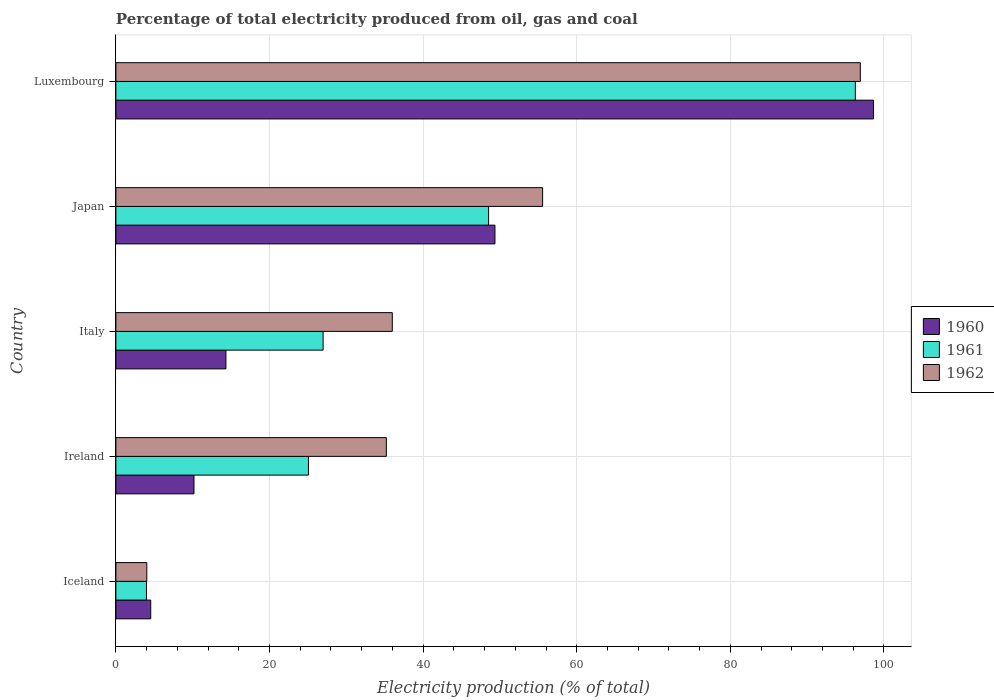How many different coloured bars are there?
Make the answer very short. 3. How many groups of bars are there?
Make the answer very short. 5. Are the number of bars on each tick of the Y-axis equal?
Give a very brief answer. Yes. How many bars are there on the 5th tick from the top?
Your response must be concise. 3. How many bars are there on the 4th tick from the bottom?
Your answer should be very brief. 3. In how many cases, is the number of bars for a given country not equal to the number of legend labels?
Provide a succinct answer. 0. What is the electricity production in in 1962 in Italy?
Your answer should be compact. 35.99. Across all countries, what is the maximum electricity production in in 1962?
Your answer should be very brief. 96.92. Across all countries, what is the minimum electricity production in in 1960?
Your answer should be compact. 4.54. In which country was the electricity production in in 1961 maximum?
Your answer should be compact. Luxembourg. What is the total electricity production in in 1962 in the graph?
Offer a terse response. 227.7. What is the difference between the electricity production in in 1961 in Iceland and that in Luxembourg?
Make the answer very short. -92.29. What is the difference between the electricity production in in 1960 in Japan and the electricity production in in 1961 in Luxembourg?
Your answer should be compact. -46.92. What is the average electricity production in in 1961 per country?
Offer a terse response. 40.16. What is the difference between the electricity production in in 1960 and electricity production in in 1961 in Japan?
Provide a short and direct response. 0.83. What is the ratio of the electricity production in in 1962 in Ireland to that in Luxembourg?
Offer a terse response. 0.36. Is the difference between the electricity production in in 1960 in Ireland and Japan greater than the difference between the electricity production in in 1961 in Ireland and Japan?
Your response must be concise. No. What is the difference between the highest and the second highest electricity production in in 1962?
Keep it short and to the point. 41.36. What is the difference between the highest and the lowest electricity production in in 1962?
Ensure brevity in your answer.  92.89. In how many countries, is the electricity production in in 1962 greater than the average electricity production in in 1962 taken over all countries?
Your response must be concise. 2. Is it the case that in every country, the sum of the electricity production in in 1960 and electricity production in in 1962 is greater than the electricity production in in 1961?
Ensure brevity in your answer.  Yes. How many bars are there?
Provide a short and direct response. 15. Are all the bars in the graph horizontal?
Provide a succinct answer. Yes. How many countries are there in the graph?
Offer a very short reply. 5. Are the values on the major ticks of X-axis written in scientific E-notation?
Your answer should be compact. No. Does the graph contain any zero values?
Ensure brevity in your answer.  No. Does the graph contain grids?
Provide a short and direct response. Yes. Where does the legend appear in the graph?
Give a very brief answer. Center right. How are the legend labels stacked?
Your response must be concise. Vertical. What is the title of the graph?
Ensure brevity in your answer.  Percentage of total electricity produced from oil, gas and coal. Does "1963" appear as one of the legend labels in the graph?
Your answer should be compact. No. What is the label or title of the X-axis?
Make the answer very short. Electricity production (% of total). What is the label or title of the Y-axis?
Your answer should be very brief. Country. What is the Electricity production (% of total) of 1960 in Iceland?
Your answer should be very brief. 4.54. What is the Electricity production (% of total) of 1961 in Iceland?
Ensure brevity in your answer.  3.98. What is the Electricity production (% of total) of 1962 in Iceland?
Your answer should be very brief. 4.03. What is the Electricity production (% of total) in 1960 in Ireland?
Keep it short and to the point. 10.17. What is the Electricity production (% of total) of 1961 in Ireland?
Provide a succinct answer. 25.07. What is the Electricity production (% of total) of 1962 in Ireland?
Provide a short and direct response. 35.21. What is the Electricity production (% of total) in 1960 in Italy?
Offer a very short reply. 14.33. What is the Electricity production (% of total) in 1961 in Italy?
Your answer should be compact. 26.98. What is the Electricity production (% of total) in 1962 in Italy?
Your answer should be very brief. 35.99. What is the Electricity production (% of total) in 1960 in Japan?
Keep it short and to the point. 49.35. What is the Electricity production (% of total) in 1961 in Japan?
Keep it short and to the point. 48.52. What is the Electricity production (% of total) in 1962 in Japan?
Your response must be concise. 55.56. What is the Electricity production (% of total) of 1960 in Luxembourg?
Keep it short and to the point. 98.63. What is the Electricity production (% of total) in 1961 in Luxembourg?
Make the answer very short. 96.27. What is the Electricity production (% of total) of 1962 in Luxembourg?
Provide a succinct answer. 96.92. Across all countries, what is the maximum Electricity production (% of total) of 1960?
Offer a terse response. 98.63. Across all countries, what is the maximum Electricity production (% of total) in 1961?
Ensure brevity in your answer.  96.27. Across all countries, what is the maximum Electricity production (% of total) of 1962?
Offer a very short reply. 96.92. Across all countries, what is the minimum Electricity production (% of total) of 1960?
Your answer should be very brief. 4.54. Across all countries, what is the minimum Electricity production (% of total) of 1961?
Keep it short and to the point. 3.98. Across all countries, what is the minimum Electricity production (% of total) in 1962?
Ensure brevity in your answer.  4.03. What is the total Electricity production (% of total) of 1960 in the graph?
Provide a succinct answer. 177.02. What is the total Electricity production (% of total) of 1961 in the graph?
Your response must be concise. 200.82. What is the total Electricity production (% of total) of 1962 in the graph?
Provide a succinct answer. 227.7. What is the difference between the Electricity production (% of total) of 1960 in Iceland and that in Ireland?
Provide a succinct answer. -5.63. What is the difference between the Electricity production (% of total) in 1961 in Iceland and that in Ireland?
Provide a short and direct response. -21.09. What is the difference between the Electricity production (% of total) of 1962 in Iceland and that in Ireland?
Give a very brief answer. -31.19. What is the difference between the Electricity production (% of total) in 1960 in Iceland and that in Italy?
Offer a terse response. -9.79. What is the difference between the Electricity production (% of total) in 1961 in Iceland and that in Italy?
Keep it short and to the point. -23. What is the difference between the Electricity production (% of total) of 1962 in Iceland and that in Italy?
Ensure brevity in your answer.  -31.96. What is the difference between the Electricity production (% of total) of 1960 in Iceland and that in Japan?
Offer a terse response. -44.81. What is the difference between the Electricity production (% of total) in 1961 in Iceland and that in Japan?
Make the answer very short. -44.54. What is the difference between the Electricity production (% of total) of 1962 in Iceland and that in Japan?
Provide a short and direct response. -51.53. What is the difference between the Electricity production (% of total) of 1960 in Iceland and that in Luxembourg?
Offer a very short reply. -94.1. What is the difference between the Electricity production (% of total) of 1961 in Iceland and that in Luxembourg?
Keep it short and to the point. -92.29. What is the difference between the Electricity production (% of total) in 1962 in Iceland and that in Luxembourg?
Ensure brevity in your answer.  -92.89. What is the difference between the Electricity production (% of total) of 1960 in Ireland and that in Italy?
Your answer should be compact. -4.16. What is the difference between the Electricity production (% of total) of 1961 in Ireland and that in Italy?
Provide a short and direct response. -1.91. What is the difference between the Electricity production (% of total) of 1962 in Ireland and that in Italy?
Ensure brevity in your answer.  -0.78. What is the difference between the Electricity production (% of total) of 1960 in Ireland and that in Japan?
Offer a terse response. -39.18. What is the difference between the Electricity production (% of total) of 1961 in Ireland and that in Japan?
Your answer should be compact. -23.45. What is the difference between the Electricity production (% of total) of 1962 in Ireland and that in Japan?
Your answer should be very brief. -20.34. What is the difference between the Electricity production (% of total) in 1960 in Ireland and that in Luxembourg?
Provide a succinct answer. -88.47. What is the difference between the Electricity production (% of total) of 1961 in Ireland and that in Luxembourg?
Give a very brief answer. -71.2. What is the difference between the Electricity production (% of total) in 1962 in Ireland and that in Luxembourg?
Offer a terse response. -61.71. What is the difference between the Electricity production (% of total) in 1960 in Italy and that in Japan?
Keep it short and to the point. -35.02. What is the difference between the Electricity production (% of total) of 1961 in Italy and that in Japan?
Your answer should be very brief. -21.55. What is the difference between the Electricity production (% of total) of 1962 in Italy and that in Japan?
Your response must be concise. -19.57. What is the difference between the Electricity production (% of total) in 1960 in Italy and that in Luxembourg?
Provide a succinct answer. -84.31. What is the difference between the Electricity production (% of total) in 1961 in Italy and that in Luxembourg?
Keep it short and to the point. -69.29. What is the difference between the Electricity production (% of total) in 1962 in Italy and that in Luxembourg?
Your answer should be very brief. -60.93. What is the difference between the Electricity production (% of total) of 1960 in Japan and that in Luxembourg?
Provide a succinct answer. -49.28. What is the difference between the Electricity production (% of total) in 1961 in Japan and that in Luxembourg?
Your response must be concise. -47.75. What is the difference between the Electricity production (% of total) of 1962 in Japan and that in Luxembourg?
Your answer should be compact. -41.36. What is the difference between the Electricity production (% of total) of 1960 in Iceland and the Electricity production (% of total) of 1961 in Ireland?
Your answer should be very brief. -20.53. What is the difference between the Electricity production (% of total) in 1960 in Iceland and the Electricity production (% of total) in 1962 in Ireland?
Give a very brief answer. -30.67. What is the difference between the Electricity production (% of total) in 1961 in Iceland and the Electricity production (% of total) in 1962 in Ireland?
Your response must be concise. -31.23. What is the difference between the Electricity production (% of total) in 1960 in Iceland and the Electricity production (% of total) in 1961 in Italy?
Make the answer very short. -22.44. What is the difference between the Electricity production (% of total) in 1960 in Iceland and the Electricity production (% of total) in 1962 in Italy?
Offer a very short reply. -31.45. What is the difference between the Electricity production (% of total) in 1961 in Iceland and the Electricity production (% of total) in 1962 in Italy?
Offer a very short reply. -32.01. What is the difference between the Electricity production (% of total) of 1960 in Iceland and the Electricity production (% of total) of 1961 in Japan?
Ensure brevity in your answer.  -43.99. What is the difference between the Electricity production (% of total) of 1960 in Iceland and the Electricity production (% of total) of 1962 in Japan?
Ensure brevity in your answer.  -51.02. What is the difference between the Electricity production (% of total) of 1961 in Iceland and the Electricity production (% of total) of 1962 in Japan?
Make the answer very short. -51.58. What is the difference between the Electricity production (% of total) in 1960 in Iceland and the Electricity production (% of total) in 1961 in Luxembourg?
Your response must be concise. -91.73. What is the difference between the Electricity production (% of total) in 1960 in Iceland and the Electricity production (% of total) in 1962 in Luxembourg?
Your response must be concise. -92.38. What is the difference between the Electricity production (% of total) in 1961 in Iceland and the Electricity production (% of total) in 1962 in Luxembourg?
Your answer should be compact. -92.94. What is the difference between the Electricity production (% of total) of 1960 in Ireland and the Electricity production (% of total) of 1961 in Italy?
Offer a very short reply. -16.81. What is the difference between the Electricity production (% of total) in 1960 in Ireland and the Electricity production (% of total) in 1962 in Italy?
Your response must be concise. -25.82. What is the difference between the Electricity production (% of total) in 1961 in Ireland and the Electricity production (% of total) in 1962 in Italy?
Your answer should be very brief. -10.92. What is the difference between the Electricity production (% of total) in 1960 in Ireland and the Electricity production (% of total) in 1961 in Japan?
Offer a very short reply. -38.36. What is the difference between the Electricity production (% of total) in 1960 in Ireland and the Electricity production (% of total) in 1962 in Japan?
Provide a short and direct response. -45.39. What is the difference between the Electricity production (% of total) in 1961 in Ireland and the Electricity production (% of total) in 1962 in Japan?
Your answer should be compact. -30.48. What is the difference between the Electricity production (% of total) in 1960 in Ireland and the Electricity production (% of total) in 1961 in Luxembourg?
Ensure brevity in your answer.  -86.1. What is the difference between the Electricity production (% of total) of 1960 in Ireland and the Electricity production (% of total) of 1962 in Luxembourg?
Provide a short and direct response. -86.75. What is the difference between the Electricity production (% of total) of 1961 in Ireland and the Electricity production (% of total) of 1962 in Luxembourg?
Provide a succinct answer. -71.85. What is the difference between the Electricity production (% of total) in 1960 in Italy and the Electricity production (% of total) in 1961 in Japan?
Offer a terse response. -34.2. What is the difference between the Electricity production (% of total) in 1960 in Italy and the Electricity production (% of total) in 1962 in Japan?
Offer a terse response. -41.23. What is the difference between the Electricity production (% of total) in 1961 in Italy and the Electricity production (% of total) in 1962 in Japan?
Give a very brief answer. -28.58. What is the difference between the Electricity production (% of total) of 1960 in Italy and the Electricity production (% of total) of 1961 in Luxembourg?
Your answer should be compact. -81.94. What is the difference between the Electricity production (% of total) in 1960 in Italy and the Electricity production (% of total) in 1962 in Luxembourg?
Your response must be concise. -82.59. What is the difference between the Electricity production (% of total) in 1961 in Italy and the Electricity production (% of total) in 1962 in Luxembourg?
Give a very brief answer. -69.94. What is the difference between the Electricity production (% of total) of 1960 in Japan and the Electricity production (% of total) of 1961 in Luxembourg?
Make the answer very short. -46.92. What is the difference between the Electricity production (% of total) of 1960 in Japan and the Electricity production (% of total) of 1962 in Luxembourg?
Your answer should be very brief. -47.57. What is the difference between the Electricity production (% of total) in 1961 in Japan and the Electricity production (% of total) in 1962 in Luxembourg?
Provide a short and direct response. -48.39. What is the average Electricity production (% of total) in 1960 per country?
Your answer should be very brief. 35.4. What is the average Electricity production (% of total) in 1961 per country?
Offer a very short reply. 40.16. What is the average Electricity production (% of total) of 1962 per country?
Make the answer very short. 45.54. What is the difference between the Electricity production (% of total) of 1960 and Electricity production (% of total) of 1961 in Iceland?
Your answer should be very brief. 0.56. What is the difference between the Electricity production (% of total) in 1960 and Electricity production (% of total) in 1962 in Iceland?
Keep it short and to the point. 0.51. What is the difference between the Electricity production (% of total) of 1961 and Electricity production (% of total) of 1962 in Iceland?
Ensure brevity in your answer.  -0.05. What is the difference between the Electricity production (% of total) in 1960 and Electricity production (% of total) in 1961 in Ireland?
Your response must be concise. -14.9. What is the difference between the Electricity production (% of total) in 1960 and Electricity production (% of total) in 1962 in Ireland?
Your answer should be compact. -25.04. What is the difference between the Electricity production (% of total) of 1961 and Electricity production (% of total) of 1962 in Ireland?
Your response must be concise. -10.14. What is the difference between the Electricity production (% of total) of 1960 and Electricity production (% of total) of 1961 in Italy?
Offer a very short reply. -12.65. What is the difference between the Electricity production (% of total) of 1960 and Electricity production (% of total) of 1962 in Italy?
Your answer should be compact. -21.66. What is the difference between the Electricity production (% of total) in 1961 and Electricity production (% of total) in 1962 in Italy?
Ensure brevity in your answer.  -9.01. What is the difference between the Electricity production (% of total) in 1960 and Electricity production (% of total) in 1961 in Japan?
Provide a succinct answer. 0.83. What is the difference between the Electricity production (% of total) in 1960 and Electricity production (% of total) in 1962 in Japan?
Offer a terse response. -6.2. What is the difference between the Electricity production (% of total) of 1961 and Electricity production (% of total) of 1962 in Japan?
Make the answer very short. -7.03. What is the difference between the Electricity production (% of total) in 1960 and Electricity production (% of total) in 1961 in Luxembourg?
Your answer should be very brief. 2.36. What is the difference between the Electricity production (% of total) in 1960 and Electricity production (% of total) in 1962 in Luxembourg?
Make the answer very short. 1.72. What is the difference between the Electricity production (% of total) of 1961 and Electricity production (% of total) of 1962 in Luxembourg?
Your answer should be very brief. -0.65. What is the ratio of the Electricity production (% of total) of 1960 in Iceland to that in Ireland?
Make the answer very short. 0.45. What is the ratio of the Electricity production (% of total) of 1961 in Iceland to that in Ireland?
Provide a succinct answer. 0.16. What is the ratio of the Electricity production (% of total) in 1962 in Iceland to that in Ireland?
Your response must be concise. 0.11. What is the ratio of the Electricity production (% of total) of 1960 in Iceland to that in Italy?
Your answer should be very brief. 0.32. What is the ratio of the Electricity production (% of total) in 1961 in Iceland to that in Italy?
Your answer should be compact. 0.15. What is the ratio of the Electricity production (% of total) of 1962 in Iceland to that in Italy?
Provide a short and direct response. 0.11. What is the ratio of the Electricity production (% of total) in 1960 in Iceland to that in Japan?
Your answer should be very brief. 0.09. What is the ratio of the Electricity production (% of total) of 1961 in Iceland to that in Japan?
Provide a short and direct response. 0.08. What is the ratio of the Electricity production (% of total) in 1962 in Iceland to that in Japan?
Ensure brevity in your answer.  0.07. What is the ratio of the Electricity production (% of total) in 1960 in Iceland to that in Luxembourg?
Provide a succinct answer. 0.05. What is the ratio of the Electricity production (% of total) of 1961 in Iceland to that in Luxembourg?
Keep it short and to the point. 0.04. What is the ratio of the Electricity production (% of total) of 1962 in Iceland to that in Luxembourg?
Provide a succinct answer. 0.04. What is the ratio of the Electricity production (% of total) in 1960 in Ireland to that in Italy?
Offer a terse response. 0.71. What is the ratio of the Electricity production (% of total) in 1961 in Ireland to that in Italy?
Keep it short and to the point. 0.93. What is the ratio of the Electricity production (% of total) of 1962 in Ireland to that in Italy?
Offer a very short reply. 0.98. What is the ratio of the Electricity production (% of total) of 1960 in Ireland to that in Japan?
Provide a succinct answer. 0.21. What is the ratio of the Electricity production (% of total) in 1961 in Ireland to that in Japan?
Provide a succinct answer. 0.52. What is the ratio of the Electricity production (% of total) in 1962 in Ireland to that in Japan?
Offer a very short reply. 0.63. What is the ratio of the Electricity production (% of total) of 1960 in Ireland to that in Luxembourg?
Your answer should be compact. 0.1. What is the ratio of the Electricity production (% of total) in 1961 in Ireland to that in Luxembourg?
Keep it short and to the point. 0.26. What is the ratio of the Electricity production (% of total) in 1962 in Ireland to that in Luxembourg?
Your answer should be very brief. 0.36. What is the ratio of the Electricity production (% of total) in 1960 in Italy to that in Japan?
Provide a succinct answer. 0.29. What is the ratio of the Electricity production (% of total) in 1961 in Italy to that in Japan?
Give a very brief answer. 0.56. What is the ratio of the Electricity production (% of total) of 1962 in Italy to that in Japan?
Make the answer very short. 0.65. What is the ratio of the Electricity production (% of total) of 1960 in Italy to that in Luxembourg?
Make the answer very short. 0.15. What is the ratio of the Electricity production (% of total) in 1961 in Italy to that in Luxembourg?
Provide a succinct answer. 0.28. What is the ratio of the Electricity production (% of total) of 1962 in Italy to that in Luxembourg?
Keep it short and to the point. 0.37. What is the ratio of the Electricity production (% of total) in 1960 in Japan to that in Luxembourg?
Provide a succinct answer. 0.5. What is the ratio of the Electricity production (% of total) in 1961 in Japan to that in Luxembourg?
Your answer should be very brief. 0.5. What is the ratio of the Electricity production (% of total) in 1962 in Japan to that in Luxembourg?
Offer a very short reply. 0.57. What is the difference between the highest and the second highest Electricity production (% of total) in 1960?
Keep it short and to the point. 49.28. What is the difference between the highest and the second highest Electricity production (% of total) in 1961?
Offer a terse response. 47.75. What is the difference between the highest and the second highest Electricity production (% of total) in 1962?
Offer a very short reply. 41.36. What is the difference between the highest and the lowest Electricity production (% of total) in 1960?
Ensure brevity in your answer.  94.1. What is the difference between the highest and the lowest Electricity production (% of total) in 1961?
Provide a succinct answer. 92.29. What is the difference between the highest and the lowest Electricity production (% of total) of 1962?
Your answer should be very brief. 92.89. 